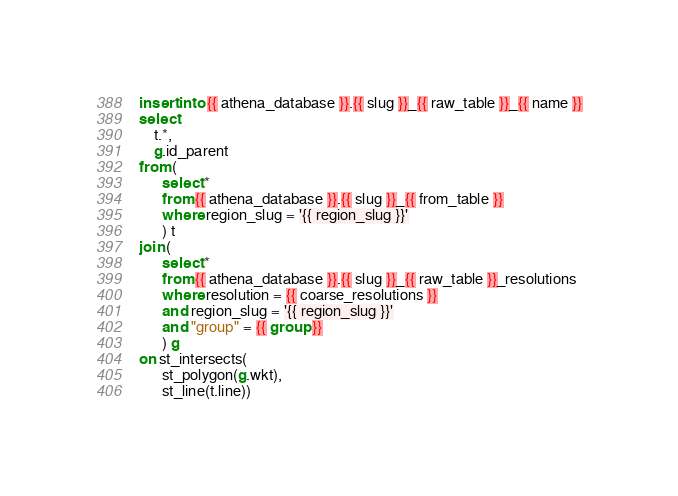Convert code to text. <code><loc_0><loc_0><loc_500><loc_500><_SQL_>insert into {{ athena_database }}.{{ slug }}_{{ raw_table }}_{{ name }}
select 
	t.*,
	g.id_parent
from (
      select * 
      from {{ athena_database }}.{{ slug }}_{{ from_table }}
      where region_slug = '{{ region_slug }}'
      ) t
join (
      select * 
      from {{ athena_database }}.{{ slug }}_{{ raw_table }}_resolutions
      where resolution = {{ coarse_resolutions }}
      and region_slug = '{{ region_slug }}'
      and "group" = {{ group }}
      ) g
on st_intersects(
      st_polygon(g.wkt),
      st_line(t.line)) </code> 